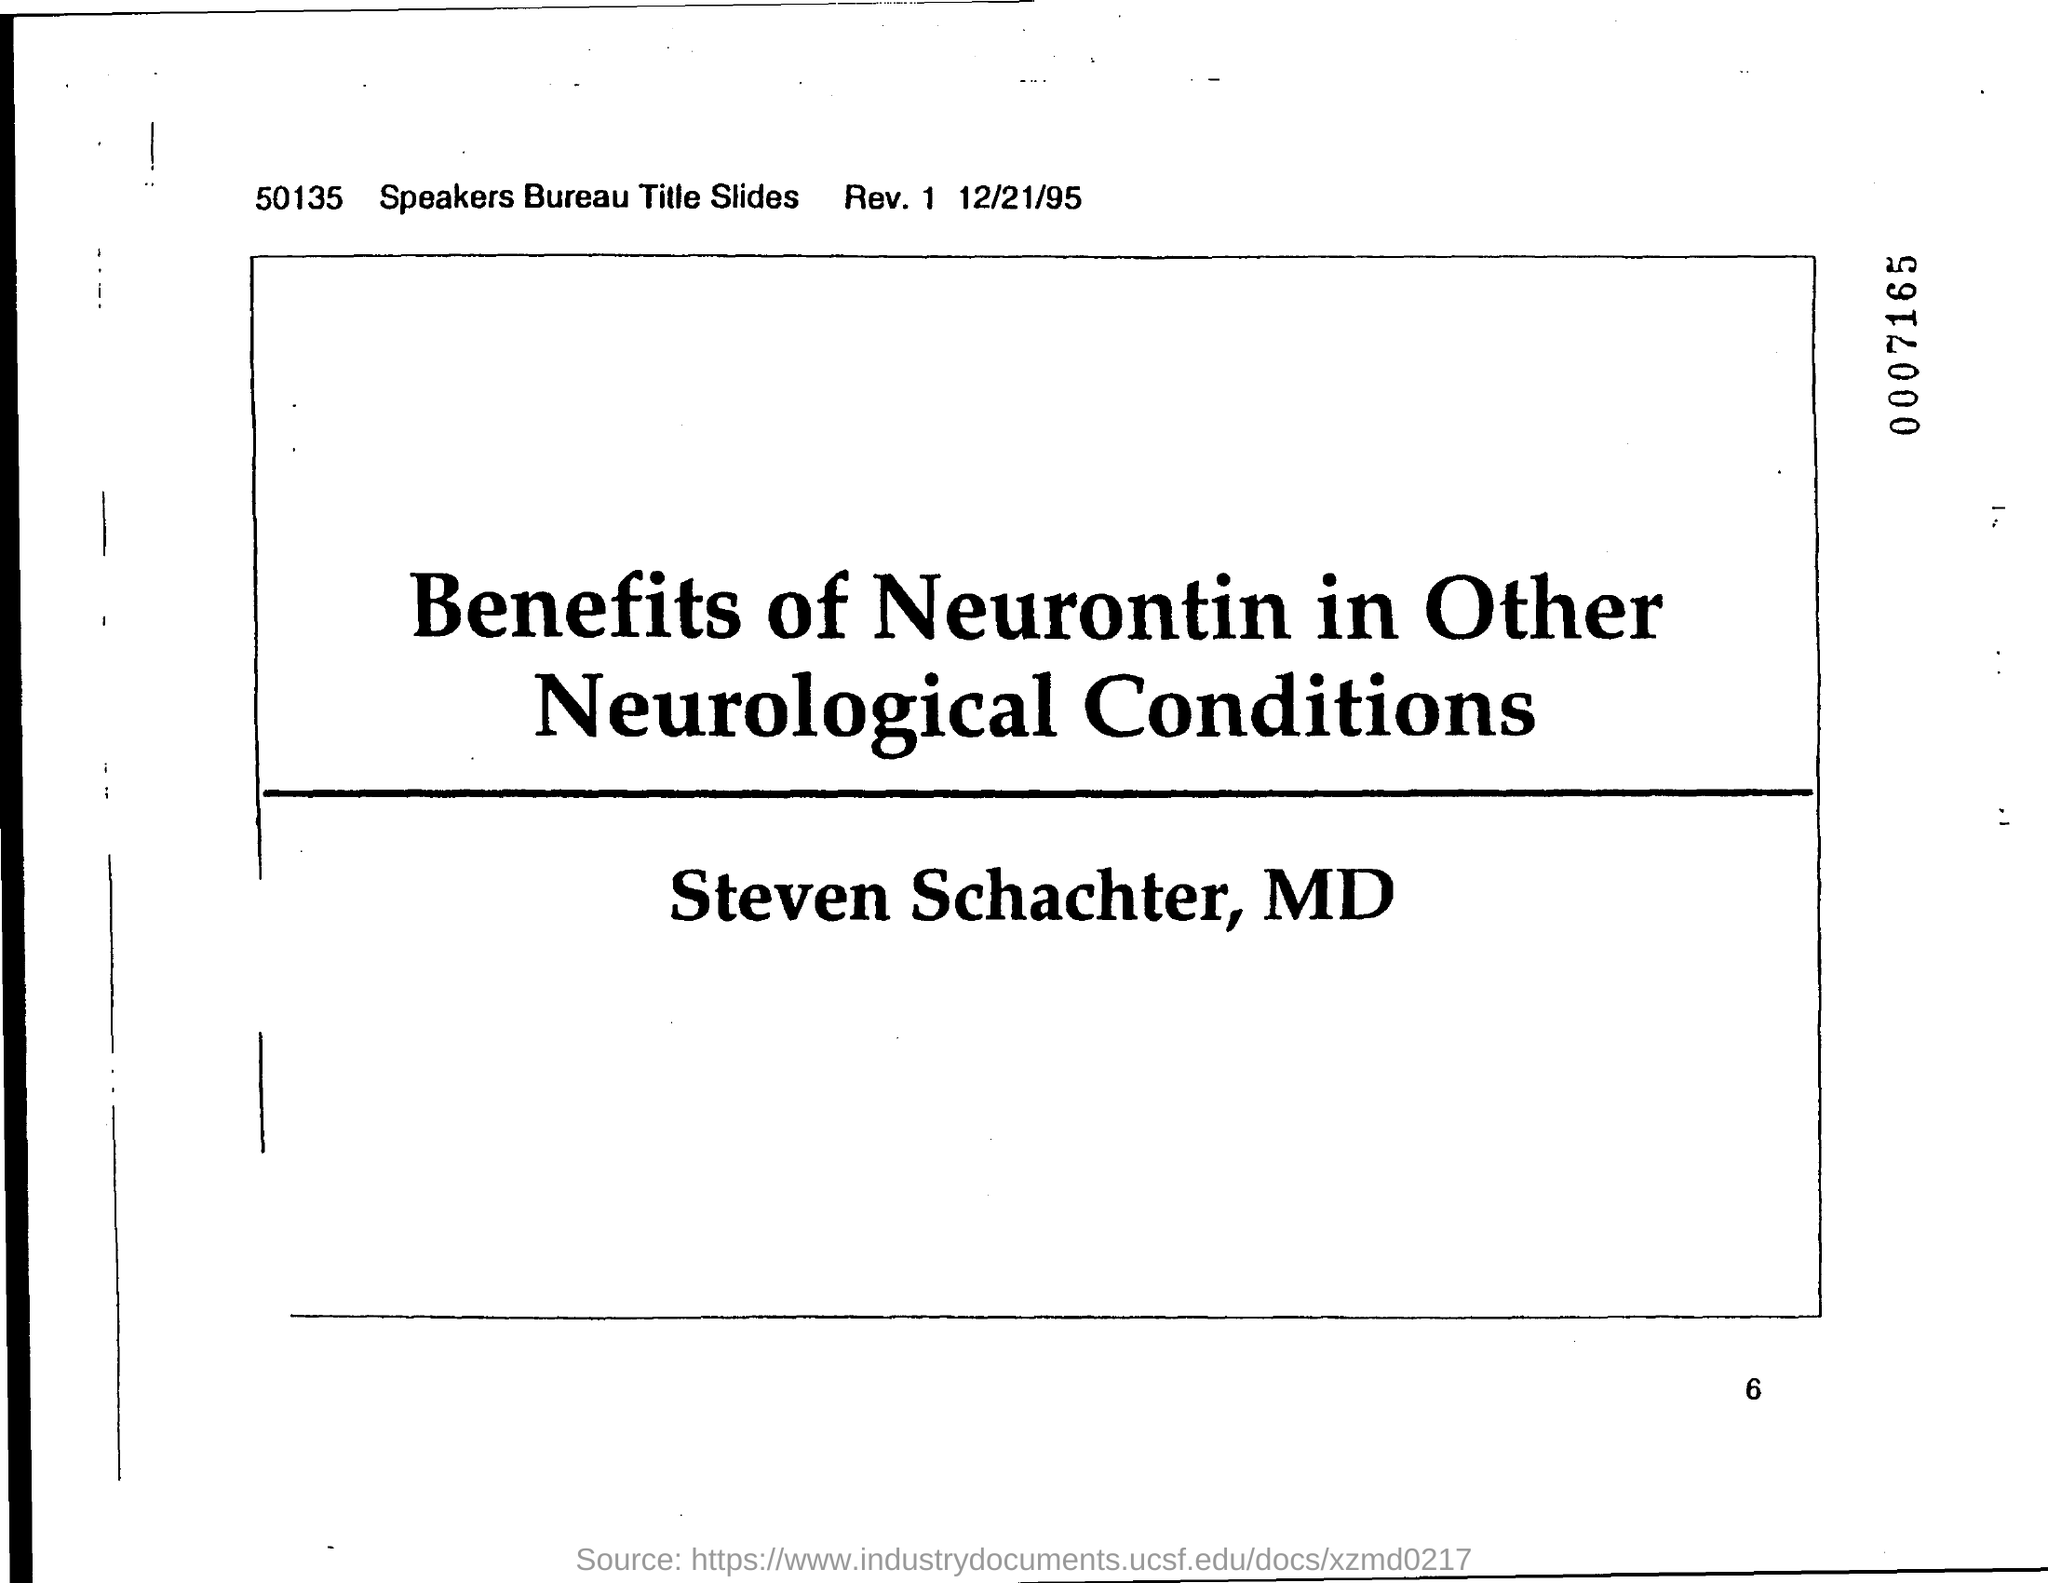Indicate a few pertinent items in this graphic. The date on the document is December 21, 1995. 